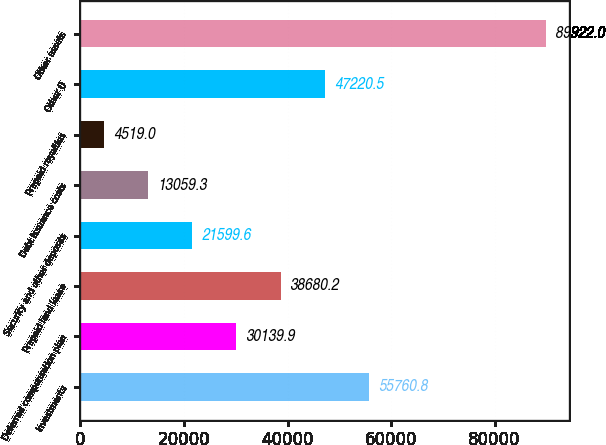Convert chart to OTSL. <chart><loc_0><loc_0><loc_500><loc_500><bar_chart><fcel>Investments<fcel>Deferred compensation plan<fcel>Prepaid land lease<fcel>Security and other deposits<fcel>Debt issuance costs<fcel>Prepaid royalties<fcel>Other ()<fcel>Other assets<nl><fcel>55760.8<fcel>30139.9<fcel>38680.2<fcel>21599.6<fcel>13059.3<fcel>4519<fcel>47220.5<fcel>89922<nl></chart> 